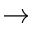<formula> <loc_0><loc_0><loc_500><loc_500>\rightarrow</formula> 